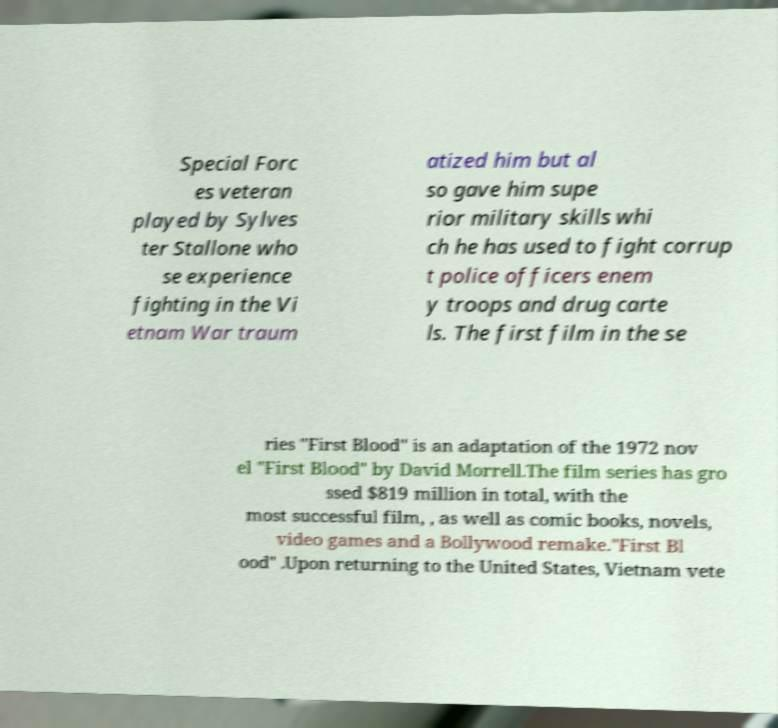For documentation purposes, I need the text within this image transcribed. Could you provide that? Special Forc es veteran played by Sylves ter Stallone who se experience fighting in the Vi etnam War traum atized him but al so gave him supe rior military skills whi ch he has used to fight corrup t police officers enem y troops and drug carte ls. The first film in the se ries "First Blood" is an adaptation of the 1972 nov el "First Blood" by David Morrell.The film series has gro ssed $819 million in total, with the most successful film, , as well as comic books, novels, video games and a Bollywood remake."First Bl ood" .Upon returning to the United States, Vietnam vete 